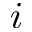Convert formula to latex. <formula><loc_0><loc_0><loc_500><loc_500>i</formula> 